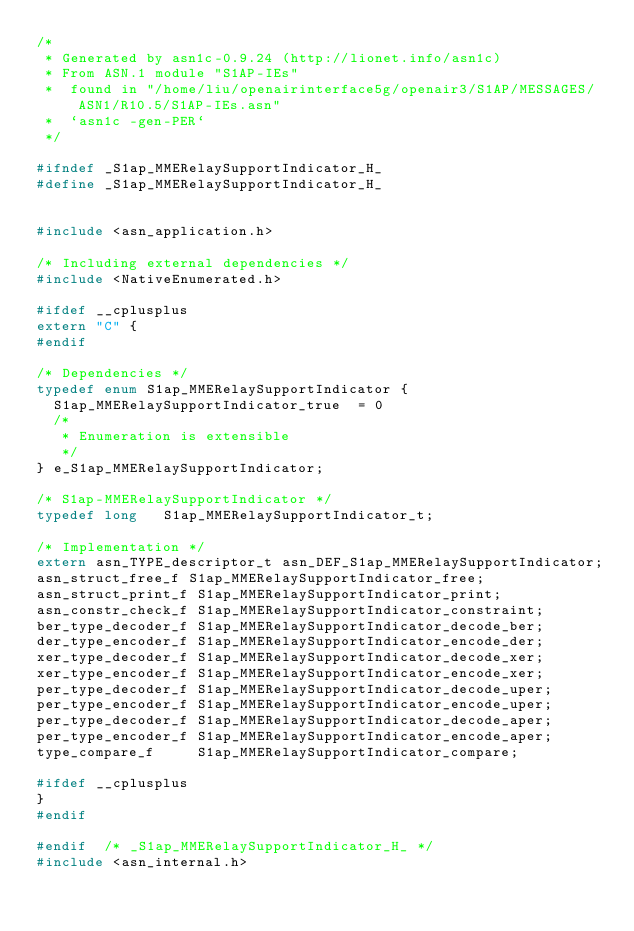Convert code to text. <code><loc_0><loc_0><loc_500><loc_500><_C_>/*
 * Generated by asn1c-0.9.24 (http://lionet.info/asn1c)
 * From ASN.1 module "S1AP-IEs"
 * 	found in "/home/liu/openairinterface5g/openair3/S1AP/MESSAGES/ASN1/R10.5/S1AP-IEs.asn"
 * 	`asn1c -gen-PER`
 */

#ifndef	_S1ap_MMERelaySupportIndicator_H_
#define	_S1ap_MMERelaySupportIndicator_H_


#include <asn_application.h>

/* Including external dependencies */
#include <NativeEnumerated.h>

#ifdef __cplusplus
extern "C" {
#endif

/* Dependencies */
typedef enum S1ap_MMERelaySupportIndicator {
	S1ap_MMERelaySupportIndicator_true	= 0
	/*
	 * Enumeration is extensible
	 */
} e_S1ap_MMERelaySupportIndicator;

/* S1ap-MMERelaySupportIndicator */
typedef long	 S1ap_MMERelaySupportIndicator_t;

/* Implementation */
extern asn_TYPE_descriptor_t asn_DEF_S1ap_MMERelaySupportIndicator;
asn_struct_free_f S1ap_MMERelaySupportIndicator_free;
asn_struct_print_f S1ap_MMERelaySupportIndicator_print;
asn_constr_check_f S1ap_MMERelaySupportIndicator_constraint;
ber_type_decoder_f S1ap_MMERelaySupportIndicator_decode_ber;
der_type_encoder_f S1ap_MMERelaySupportIndicator_encode_der;
xer_type_decoder_f S1ap_MMERelaySupportIndicator_decode_xer;
xer_type_encoder_f S1ap_MMERelaySupportIndicator_encode_xer;
per_type_decoder_f S1ap_MMERelaySupportIndicator_decode_uper;
per_type_encoder_f S1ap_MMERelaySupportIndicator_encode_uper;
per_type_decoder_f S1ap_MMERelaySupportIndicator_decode_aper;
per_type_encoder_f S1ap_MMERelaySupportIndicator_encode_aper;
type_compare_f     S1ap_MMERelaySupportIndicator_compare;

#ifdef __cplusplus
}
#endif

#endif	/* _S1ap_MMERelaySupportIndicator_H_ */
#include <asn_internal.h>
</code> 